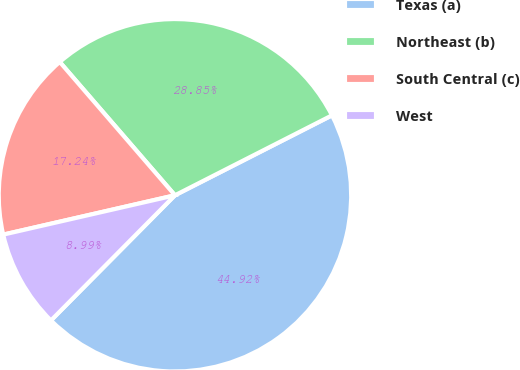Convert chart to OTSL. <chart><loc_0><loc_0><loc_500><loc_500><pie_chart><fcel>Texas (a)<fcel>Northeast (b)<fcel>South Central (c)<fcel>West<nl><fcel>44.92%<fcel>28.85%<fcel>17.24%<fcel>8.99%<nl></chart> 